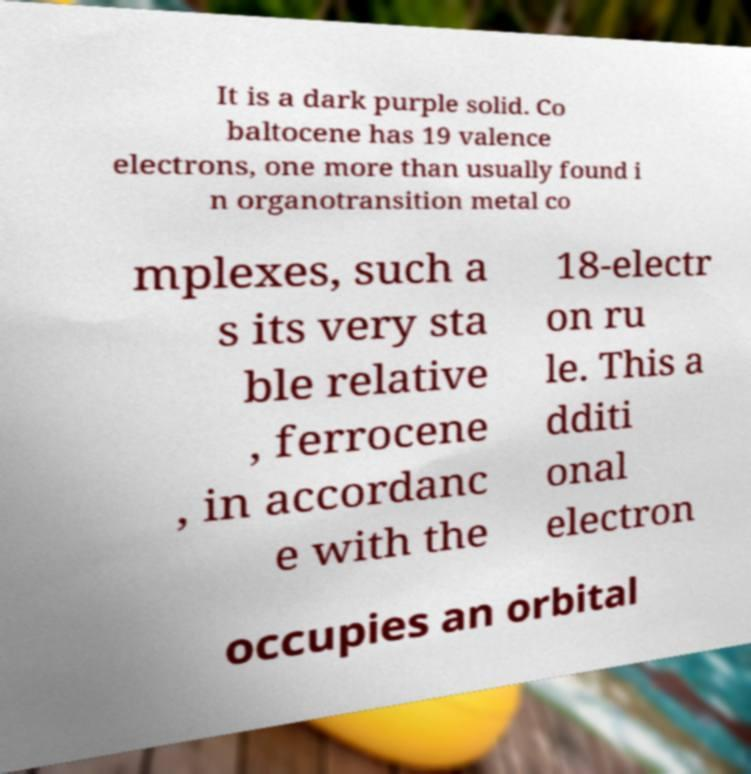Can you read and provide the text displayed in the image?This photo seems to have some interesting text. Can you extract and type it out for me? It is a dark purple solid. Co baltocene has 19 valence electrons, one more than usually found i n organotransition metal co mplexes, such a s its very sta ble relative , ferrocene , in accordanc e with the 18-electr on ru le. This a dditi onal electron occupies an orbital 